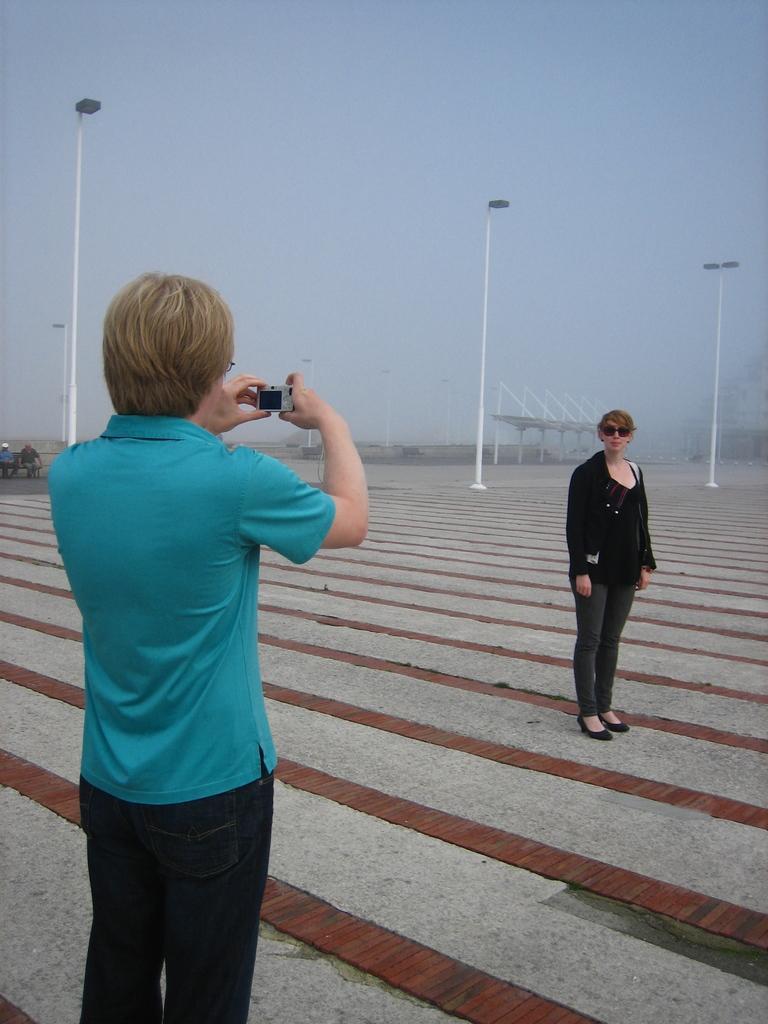In one or two sentences, can you explain what this image depicts? On the left side of the image we can see a person standing and he is holding some object. In the center of the image, we can see a person standing and wearing glasses and she is in a different costume. In the background, we can see the sky, poles, few people and a few other objects. 